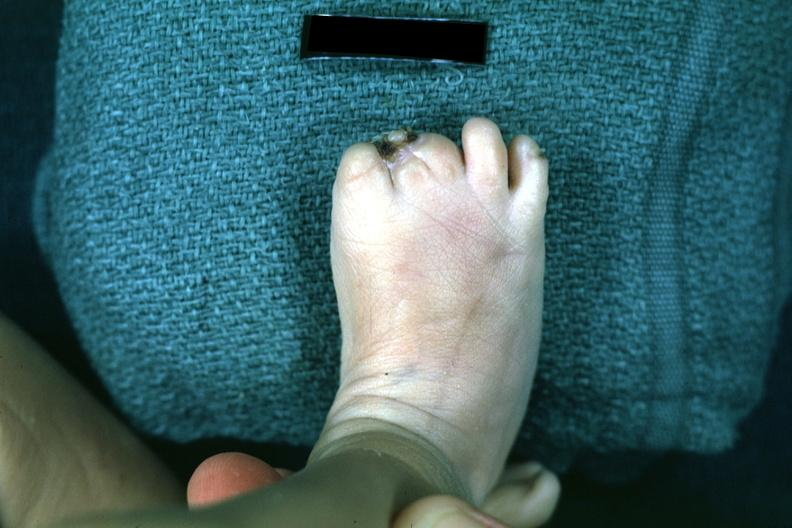s foot present?
Answer the question using a single word or phrase. Yes 